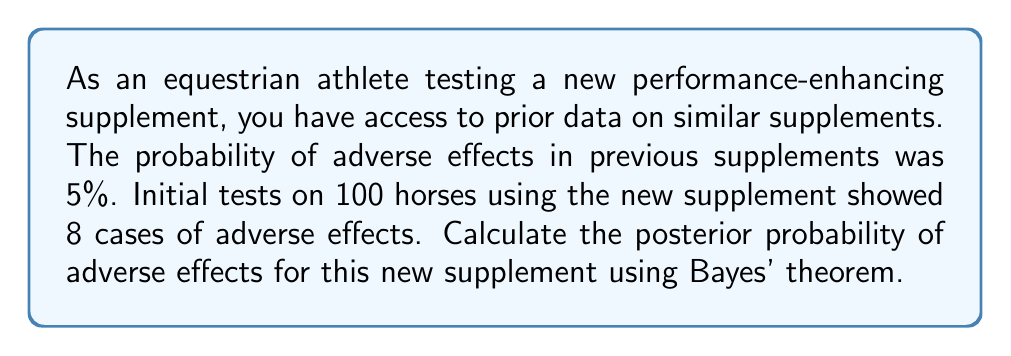Solve this math problem. To solve this problem, we'll use Bayes' theorem:

$$ P(A|B) = \frac{P(B|A) \cdot P(A)}{P(B)} $$

Where:
A = Event of adverse effects
B = Observed data (8 out of 100 horses showing adverse effects)

1. Prior probability P(A) = 0.05 (5% from previous data)

2. Likelihood P(B|A): We can model this as a binomial distribution
   $$ P(B|A) = \binom{100}{8} \cdot 0.05^8 \cdot 0.95^{92} \approx 0.0392 $$

3. To calculate P(B), we use the law of total probability:
   $$ P(B) = P(B|A) \cdot P(A) + P(B|\text{not}A) \cdot P(\text{not}A) $$
   
   We need P(B|not A), which we can model as:
   $$ P(B|\text{not}A) = \binom{100}{8} \cdot 0.08^8 \cdot 0.92^{92} \approx 0.1799 $$
   (assuming 8% chance of adverse effects when the supplement is not causing them)

   Now we can calculate P(B):
   $$ P(B) = 0.0392 \cdot 0.05 + 0.1799 \cdot 0.95 \approx 0.1730 $$

4. Applying Bayes' theorem:
   $$ P(A|B) = \frac{0.0392 \cdot 0.05}{0.1730} \approx 0.0113 $$

Therefore, the posterior probability of adverse effects is approximately 0.0113 or 1.13%.
Answer: The posterior probability of adverse effects for the new supplement is approximately 0.0113 or 1.13%. 